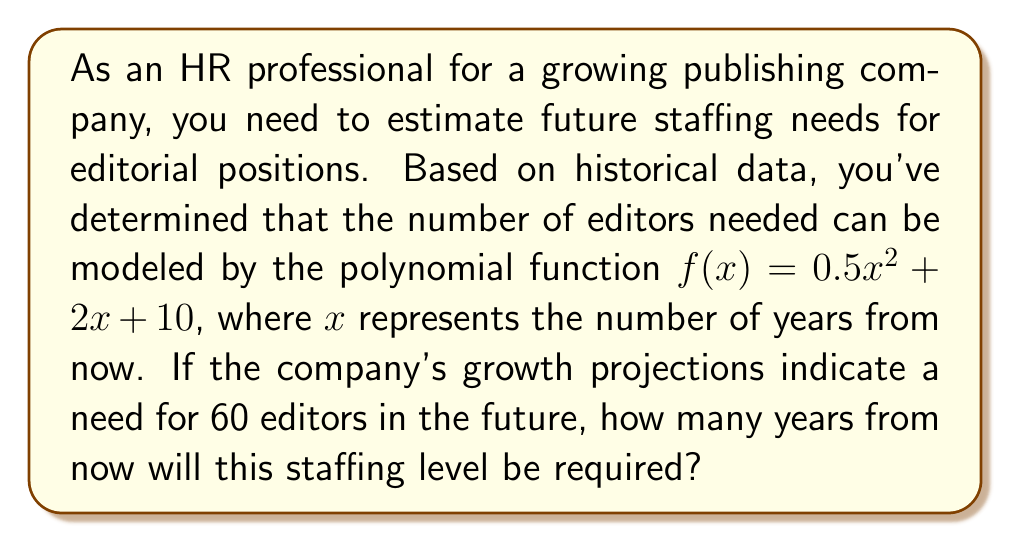Can you answer this question? To solve this problem, we need to find the value of $x$ that satisfies the equation $f(x) = 60$. Let's approach this step-by-step:

1) We start with the given polynomial function:
   $f(x) = 0.5x^2 + 2x + 10$

2) We want to find $x$ when $f(x) = 60$, so we set up the equation:
   $0.5x^2 + 2x + 10 = 60$

3) Subtract 60 from both sides to get the equation in standard form:
   $0.5x^2 + 2x - 50 = 0$

4) This is a quadratic equation. We can solve it using the quadratic formula:
   $x = \frac{-b \pm \sqrt{b^2 - 4ac}}{2a}$

   Where $a = 0.5$, $b = 2$, and $c = -50$

5) Substituting these values into the quadratic formula:
   $x = \frac{-2 \pm \sqrt{2^2 - 4(0.5)(-50)}}{2(0.5)}$

6) Simplify under the square root:
   $x = \frac{-2 \pm \sqrt{4 + 100}}{1} = -2 \pm \sqrt{104}$

7) Simplify further:
   $x = -2 \pm 10.198$

8) This gives us two solutions:
   $x_1 = -2 + 10.198 = 8.198$
   $x_2 = -2 - 10.198 = -12.198$

9) Since we're dealing with future years, we can discard the negative solution.

Therefore, the company will need 60 editors approximately 8.2 years from now.
Answer: 8.2 years (rounded to one decimal place) 